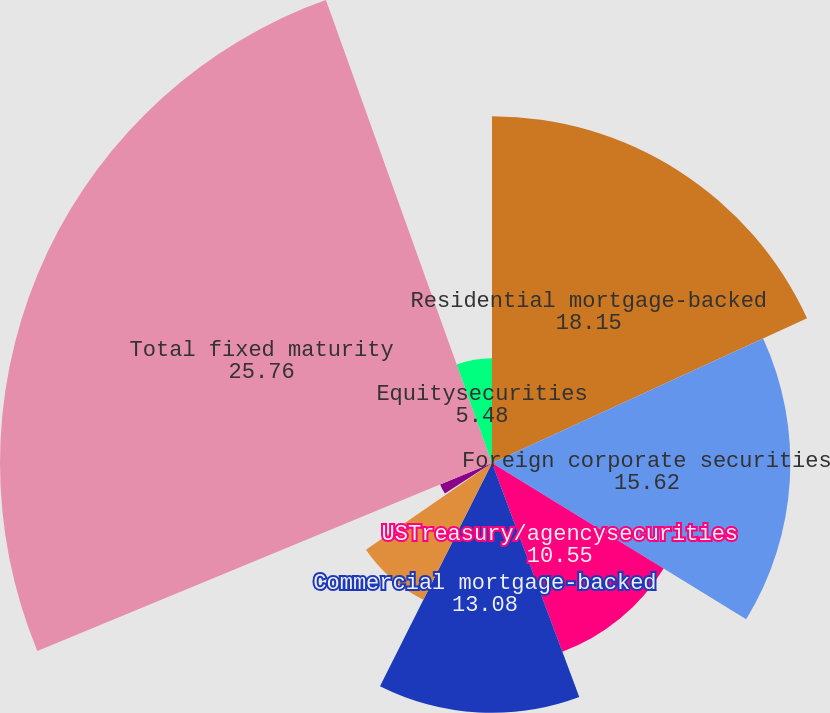Convert chart. <chart><loc_0><loc_0><loc_500><loc_500><pie_chart><fcel>Residential mortgage-backed<fcel>Foreign corporate securities<fcel>USTreasury/agencysecurities<fcel>Commercial mortgage-backed<fcel>Asset-backedsecurities<fcel>Foreigngovernmentsecurities<fcel>Otherfixedmaturitysecurities<fcel>Total fixed maturity<fcel>Equitysecurities<nl><fcel>18.15%<fcel>15.62%<fcel>10.55%<fcel>13.08%<fcel>8.01%<fcel>0.41%<fcel>2.94%<fcel>25.76%<fcel>5.48%<nl></chart> 